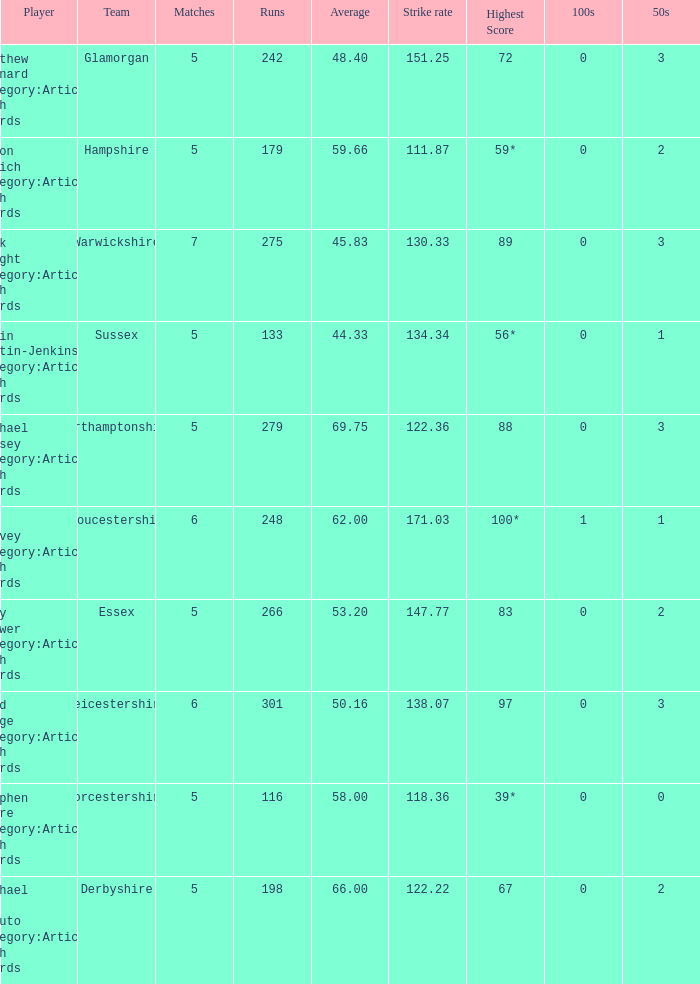If the highest score is 88, what are the 50s? 3.0. 